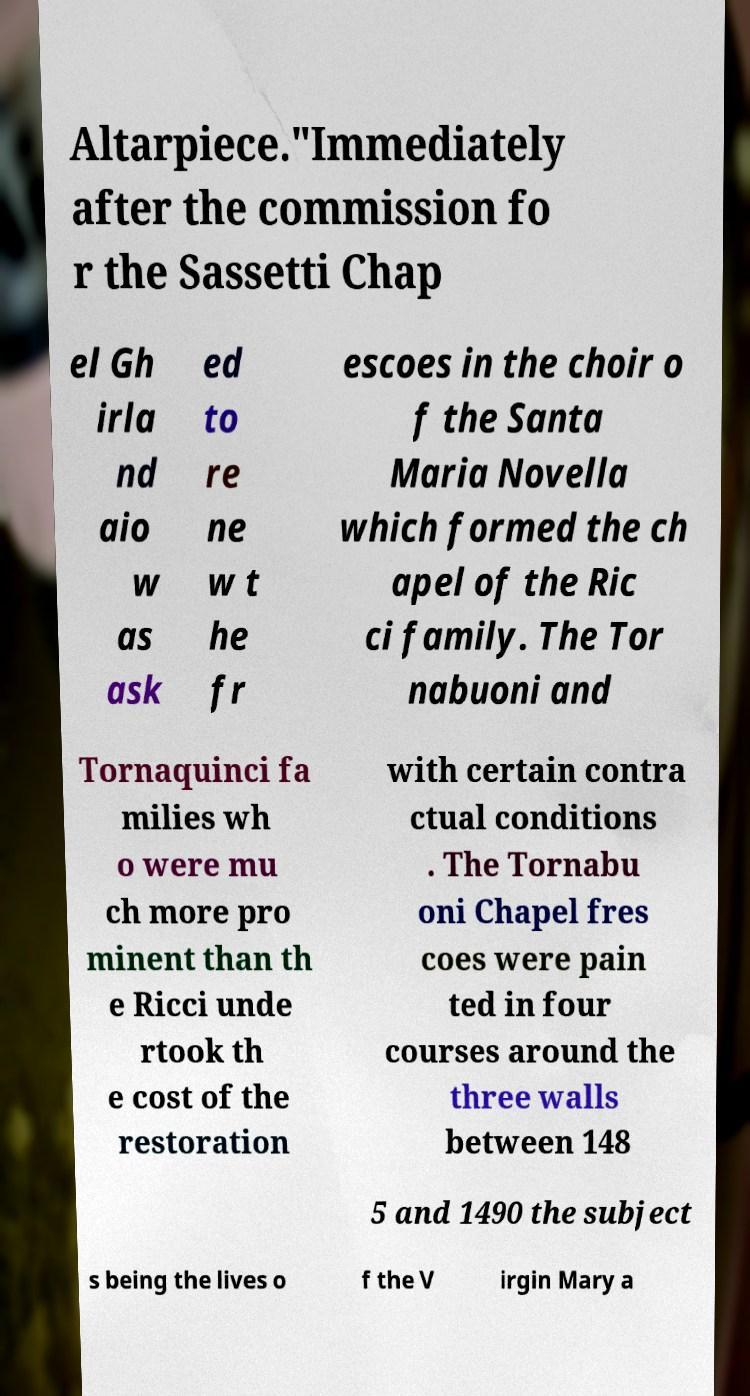Could you extract and type out the text from this image? Altarpiece."Immediately after the commission fo r the Sassetti Chap el Gh irla nd aio w as ask ed to re ne w t he fr escoes in the choir o f the Santa Maria Novella which formed the ch apel of the Ric ci family. The Tor nabuoni and Tornaquinci fa milies wh o were mu ch more pro minent than th e Ricci unde rtook th e cost of the restoration with certain contra ctual conditions . The Tornabu oni Chapel fres coes were pain ted in four courses around the three walls between 148 5 and 1490 the subject s being the lives o f the V irgin Mary a 